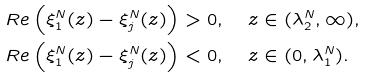<formula> <loc_0><loc_0><loc_500><loc_500>R e \left ( \xi _ { 1 } ^ { N } ( z ) - \xi _ { j } ^ { N } ( z ) \right ) & > 0 , \quad z \in ( \lambda _ { 2 } ^ { N } , \infty ) , \\ R e \left ( \xi _ { 1 } ^ { N } ( z ) - \xi _ { j } ^ { N } ( z ) \right ) & < 0 , \quad z \in ( 0 , \lambda _ { 1 } ^ { N } ) .</formula> 